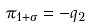<formula> <loc_0><loc_0><loc_500><loc_500>\pi _ { 1 + \sigma } = - q _ { 2 }</formula> 